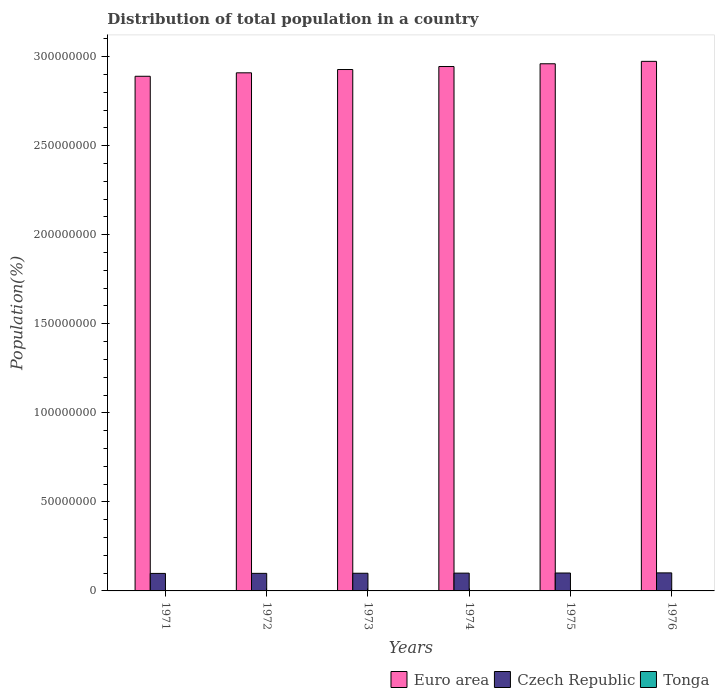How many different coloured bars are there?
Your response must be concise. 3. Are the number of bars per tick equal to the number of legend labels?
Provide a succinct answer. Yes. Are the number of bars on each tick of the X-axis equal?
Your answer should be very brief. Yes. How many bars are there on the 3rd tick from the left?
Ensure brevity in your answer.  3. How many bars are there on the 1st tick from the right?
Provide a short and direct response. 3. What is the label of the 6th group of bars from the left?
Make the answer very short. 1976. In how many cases, is the number of bars for a given year not equal to the number of legend labels?
Offer a terse response. 0. What is the population of in Tonga in 1974?
Offer a very short reply. 8.76e+04. Across all years, what is the maximum population of in Euro area?
Provide a succinct answer. 2.97e+08. Across all years, what is the minimum population of in Euro area?
Offer a terse response. 2.89e+08. In which year was the population of in Czech Republic maximum?
Offer a terse response. 1976. What is the total population of in Czech Republic in the graph?
Offer a terse response. 5.98e+07. What is the difference between the population of in Euro area in 1975 and that in 1976?
Your answer should be compact. -1.36e+06. What is the difference between the population of in Tonga in 1976 and the population of in Euro area in 1972?
Ensure brevity in your answer.  -2.91e+08. What is the average population of in Euro area per year?
Give a very brief answer. 2.93e+08. In the year 1972, what is the difference between the population of in Tonga and population of in Czech Republic?
Offer a very short reply. -9.78e+06. In how many years, is the population of in Czech Republic greater than 260000000 %?
Provide a short and direct response. 0. What is the ratio of the population of in Czech Republic in 1971 to that in 1973?
Offer a very short reply. 0.99. Is the population of in Euro area in 1973 less than that in 1975?
Keep it short and to the point. Yes. Is the difference between the population of in Tonga in 1972 and 1974 greater than the difference between the population of in Czech Republic in 1972 and 1974?
Your answer should be very brief. Yes. What is the difference between the highest and the second highest population of in Czech Republic?
Keep it short and to the point. 6.73e+04. What is the difference between the highest and the lowest population of in Tonga?
Offer a very short reply. 3738. What does the 2nd bar from the left in 1976 represents?
Give a very brief answer. Czech Republic. What does the 3rd bar from the right in 1973 represents?
Provide a short and direct response. Euro area. What is the difference between two consecutive major ticks on the Y-axis?
Your answer should be very brief. 5.00e+07. Are the values on the major ticks of Y-axis written in scientific E-notation?
Offer a very short reply. No. Where does the legend appear in the graph?
Your answer should be compact. Bottom right. How many legend labels are there?
Ensure brevity in your answer.  3. What is the title of the graph?
Ensure brevity in your answer.  Distribution of total population in a country. What is the label or title of the X-axis?
Ensure brevity in your answer.  Years. What is the label or title of the Y-axis?
Provide a succinct answer. Population(%). What is the Population(%) of Euro area in 1971?
Offer a very short reply. 2.89e+08. What is the Population(%) of Czech Republic in 1971?
Keep it short and to the point. 9.83e+06. What is the Population(%) in Tonga in 1971?
Ensure brevity in your answer.  8.55e+04. What is the Population(%) of Euro area in 1972?
Offer a very short reply. 2.91e+08. What is the Population(%) of Czech Republic in 1972?
Offer a terse response. 9.87e+06. What is the Population(%) of Tonga in 1972?
Provide a short and direct response. 8.63e+04. What is the Population(%) in Euro area in 1973?
Give a very brief answer. 2.93e+08. What is the Population(%) in Czech Republic in 1973?
Your answer should be very brief. 9.92e+06. What is the Population(%) in Tonga in 1973?
Offer a terse response. 8.70e+04. What is the Population(%) of Euro area in 1974?
Make the answer very short. 2.94e+08. What is the Population(%) of Czech Republic in 1974?
Provide a short and direct response. 9.99e+06. What is the Population(%) of Tonga in 1974?
Offer a terse response. 8.76e+04. What is the Population(%) in Euro area in 1975?
Your answer should be compact. 2.96e+08. What is the Population(%) in Czech Republic in 1975?
Give a very brief answer. 1.01e+07. What is the Population(%) of Tonga in 1975?
Keep it short and to the point. 8.83e+04. What is the Population(%) of Euro area in 1976?
Provide a short and direct response. 2.97e+08. What is the Population(%) in Czech Republic in 1976?
Offer a very short reply. 1.01e+07. What is the Population(%) of Tonga in 1976?
Your response must be concise. 8.93e+04. Across all years, what is the maximum Population(%) in Euro area?
Offer a very short reply. 2.97e+08. Across all years, what is the maximum Population(%) in Czech Republic?
Ensure brevity in your answer.  1.01e+07. Across all years, what is the maximum Population(%) in Tonga?
Provide a succinct answer. 8.93e+04. Across all years, what is the minimum Population(%) of Euro area?
Your answer should be compact. 2.89e+08. Across all years, what is the minimum Population(%) of Czech Republic?
Offer a terse response. 9.83e+06. Across all years, what is the minimum Population(%) in Tonga?
Offer a terse response. 8.55e+04. What is the total Population(%) in Euro area in the graph?
Give a very brief answer. 1.76e+09. What is the total Population(%) in Czech Republic in the graph?
Your response must be concise. 5.98e+07. What is the total Population(%) in Tonga in the graph?
Your answer should be compact. 5.24e+05. What is the difference between the Population(%) in Euro area in 1971 and that in 1972?
Offer a terse response. -1.94e+06. What is the difference between the Population(%) in Czech Republic in 1971 and that in 1972?
Provide a short and direct response. -4.08e+04. What is the difference between the Population(%) in Tonga in 1971 and that in 1972?
Provide a short and direct response. -829. What is the difference between the Population(%) in Euro area in 1971 and that in 1973?
Provide a succinct answer. -3.79e+06. What is the difference between the Population(%) of Czech Republic in 1971 and that in 1973?
Offer a very short reply. -9.55e+04. What is the difference between the Population(%) in Tonga in 1971 and that in 1973?
Ensure brevity in your answer.  -1465. What is the difference between the Population(%) of Euro area in 1971 and that in 1974?
Provide a short and direct response. -5.47e+06. What is the difference between the Population(%) in Czech Republic in 1971 and that in 1974?
Your answer should be compact. -1.62e+05. What is the difference between the Population(%) in Tonga in 1971 and that in 1974?
Give a very brief answer. -2089. What is the difference between the Population(%) of Euro area in 1971 and that in 1975?
Your answer should be compact. -7.02e+06. What is the difference between the Population(%) in Czech Republic in 1971 and that in 1975?
Offer a very short reply. -2.32e+05. What is the difference between the Population(%) in Tonga in 1971 and that in 1975?
Make the answer very short. -2827. What is the difference between the Population(%) in Euro area in 1971 and that in 1976?
Make the answer very short. -8.37e+06. What is the difference between the Population(%) of Czech Republic in 1971 and that in 1976?
Give a very brief answer. -2.99e+05. What is the difference between the Population(%) in Tonga in 1971 and that in 1976?
Your answer should be very brief. -3738. What is the difference between the Population(%) in Euro area in 1972 and that in 1973?
Offer a very short reply. -1.85e+06. What is the difference between the Population(%) of Czech Republic in 1972 and that in 1973?
Your answer should be compact. -5.46e+04. What is the difference between the Population(%) of Tonga in 1972 and that in 1973?
Give a very brief answer. -636. What is the difference between the Population(%) of Euro area in 1972 and that in 1974?
Provide a short and direct response. -3.53e+06. What is the difference between the Population(%) in Czech Republic in 1972 and that in 1974?
Offer a terse response. -1.21e+05. What is the difference between the Population(%) of Tonga in 1972 and that in 1974?
Keep it short and to the point. -1260. What is the difference between the Population(%) in Euro area in 1972 and that in 1975?
Provide a short and direct response. -5.08e+06. What is the difference between the Population(%) in Czech Republic in 1972 and that in 1975?
Keep it short and to the point. -1.91e+05. What is the difference between the Population(%) of Tonga in 1972 and that in 1975?
Provide a succinct answer. -1998. What is the difference between the Population(%) of Euro area in 1972 and that in 1976?
Keep it short and to the point. -6.44e+06. What is the difference between the Population(%) in Czech Republic in 1972 and that in 1976?
Ensure brevity in your answer.  -2.58e+05. What is the difference between the Population(%) in Tonga in 1972 and that in 1976?
Keep it short and to the point. -2909. What is the difference between the Population(%) in Euro area in 1973 and that in 1974?
Offer a terse response. -1.68e+06. What is the difference between the Population(%) of Czech Republic in 1973 and that in 1974?
Provide a succinct answer. -6.62e+04. What is the difference between the Population(%) in Tonga in 1973 and that in 1974?
Your answer should be very brief. -624. What is the difference between the Population(%) in Euro area in 1973 and that in 1975?
Your response must be concise. -3.23e+06. What is the difference between the Population(%) of Czech Republic in 1973 and that in 1975?
Your answer should be compact. -1.36e+05. What is the difference between the Population(%) in Tonga in 1973 and that in 1975?
Your answer should be very brief. -1362. What is the difference between the Population(%) in Euro area in 1973 and that in 1976?
Provide a short and direct response. -4.58e+06. What is the difference between the Population(%) in Czech Republic in 1973 and that in 1976?
Make the answer very short. -2.04e+05. What is the difference between the Population(%) of Tonga in 1973 and that in 1976?
Your answer should be very brief. -2273. What is the difference between the Population(%) in Euro area in 1974 and that in 1975?
Make the answer very short. -1.55e+06. What is the difference between the Population(%) of Czech Republic in 1974 and that in 1975?
Provide a succinct answer. -7.02e+04. What is the difference between the Population(%) in Tonga in 1974 and that in 1975?
Give a very brief answer. -738. What is the difference between the Population(%) of Euro area in 1974 and that in 1976?
Your answer should be very brief. -2.90e+06. What is the difference between the Population(%) in Czech Republic in 1974 and that in 1976?
Your answer should be compact. -1.37e+05. What is the difference between the Population(%) in Tonga in 1974 and that in 1976?
Your answer should be very brief. -1649. What is the difference between the Population(%) in Euro area in 1975 and that in 1976?
Make the answer very short. -1.36e+06. What is the difference between the Population(%) in Czech Republic in 1975 and that in 1976?
Offer a terse response. -6.73e+04. What is the difference between the Population(%) of Tonga in 1975 and that in 1976?
Offer a very short reply. -911. What is the difference between the Population(%) in Euro area in 1971 and the Population(%) in Czech Republic in 1972?
Provide a short and direct response. 2.79e+08. What is the difference between the Population(%) in Euro area in 1971 and the Population(%) in Tonga in 1972?
Provide a succinct answer. 2.89e+08. What is the difference between the Population(%) in Czech Republic in 1971 and the Population(%) in Tonga in 1972?
Give a very brief answer. 9.74e+06. What is the difference between the Population(%) in Euro area in 1971 and the Population(%) in Czech Republic in 1973?
Provide a succinct answer. 2.79e+08. What is the difference between the Population(%) of Euro area in 1971 and the Population(%) of Tonga in 1973?
Your response must be concise. 2.89e+08. What is the difference between the Population(%) of Czech Republic in 1971 and the Population(%) of Tonga in 1973?
Your answer should be very brief. 9.74e+06. What is the difference between the Population(%) in Euro area in 1971 and the Population(%) in Czech Republic in 1974?
Make the answer very short. 2.79e+08. What is the difference between the Population(%) in Euro area in 1971 and the Population(%) in Tonga in 1974?
Make the answer very short. 2.89e+08. What is the difference between the Population(%) of Czech Republic in 1971 and the Population(%) of Tonga in 1974?
Your response must be concise. 9.74e+06. What is the difference between the Population(%) of Euro area in 1971 and the Population(%) of Czech Republic in 1975?
Your answer should be compact. 2.79e+08. What is the difference between the Population(%) of Euro area in 1971 and the Population(%) of Tonga in 1975?
Your response must be concise. 2.89e+08. What is the difference between the Population(%) of Czech Republic in 1971 and the Population(%) of Tonga in 1975?
Provide a short and direct response. 9.74e+06. What is the difference between the Population(%) in Euro area in 1971 and the Population(%) in Czech Republic in 1976?
Your response must be concise. 2.79e+08. What is the difference between the Population(%) of Euro area in 1971 and the Population(%) of Tonga in 1976?
Ensure brevity in your answer.  2.89e+08. What is the difference between the Population(%) of Czech Republic in 1971 and the Population(%) of Tonga in 1976?
Your response must be concise. 9.74e+06. What is the difference between the Population(%) of Euro area in 1972 and the Population(%) of Czech Republic in 1973?
Keep it short and to the point. 2.81e+08. What is the difference between the Population(%) of Euro area in 1972 and the Population(%) of Tonga in 1973?
Make the answer very short. 2.91e+08. What is the difference between the Population(%) of Czech Republic in 1972 and the Population(%) of Tonga in 1973?
Your answer should be very brief. 9.78e+06. What is the difference between the Population(%) in Euro area in 1972 and the Population(%) in Czech Republic in 1974?
Your answer should be very brief. 2.81e+08. What is the difference between the Population(%) in Euro area in 1972 and the Population(%) in Tonga in 1974?
Provide a succinct answer. 2.91e+08. What is the difference between the Population(%) of Czech Republic in 1972 and the Population(%) of Tonga in 1974?
Your response must be concise. 9.78e+06. What is the difference between the Population(%) in Euro area in 1972 and the Population(%) in Czech Republic in 1975?
Your answer should be compact. 2.81e+08. What is the difference between the Population(%) in Euro area in 1972 and the Population(%) in Tonga in 1975?
Your answer should be very brief. 2.91e+08. What is the difference between the Population(%) in Czech Republic in 1972 and the Population(%) in Tonga in 1975?
Offer a terse response. 9.78e+06. What is the difference between the Population(%) in Euro area in 1972 and the Population(%) in Czech Republic in 1976?
Offer a very short reply. 2.81e+08. What is the difference between the Population(%) in Euro area in 1972 and the Population(%) in Tonga in 1976?
Make the answer very short. 2.91e+08. What is the difference between the Population(%) in Czech Republic in 1972 and the Population(%) in Tonga in 1976?
Ensure brevity in your answer.  9.78e+06. What is the difference between the Population(%) of Euro area in 1973 and the Population(%) of Czech Republic in 1974?
Provide a succinct answer. 2.83e+08. What is the difference between the Population(%) in Euro area in 1973 and the Population(%) in Tonga in 1974?
Offer a very short reply. 2.93e+08. What is the difference between the Population(%) of Czech Republic in 1973 and the Population(%) of Tonga in 1974?
Provide a succinct answer. 9.83e+06. What is the difference between the Population(%) of Euro area in 1973 and the Population(%) of Czech Republic in 1975?
Make the answer very short. 2.83e+08. What is the difference between the Population(%) in Euro area in 1973 and the Population(%) in Tonga in 1975?
Keep it short and to the point. 2.93e+08. What is the difference between the Population(%) of Czech Republic in 1973 and the Population(%) of Tonga in 1975?
Offer a very short reply. 9.83e+06. What is the difference between the Population(%) of Euro area in 1973 and the Population(%) of Czech Republic in 1976?
Offer a very short reply. 2.83e+08. What is the difference between the Population(%) of Euro area in 1973 and the Population(%) of Tonga in 1976?
Provide a succinct answer. 2.93e+08. What is the difference between the Population(%) of Czech Republic in 1973 and the Population(%) of Tonga in 1976?
Give a very brief answer. 9.83e+06. What is the difference between the Population(%) of Euro area in 1974 and the Population(%) of Czech Republic in 1975?
Make the answer very short. 2.84e+08. What is the difference between the Population(%) of Euro area in 1974 and the Population(%) of Tonga in 1975?
Provide a short and direct response. 2.94e+08. What is the difference between the Population(%) in Czech Republic in 1974 and the Population(%) in Tonga in 1975?
Ensure brevity in your answer.  9.90e+06. What is the difference between the Population(%) in Euro area in 1974 and the Population(%) in Czech Republic in 1976?
Keep it short and to the point. 2.84e+08. What is the difference between the Population(%) in Euro area in 1974 and the Population(%) in Tonga in 1976?
Your answer should be compact. 2.94e+08. What is the difference between the Population(%) of Czech Republic in 1974 and the Population(%) of Tonga in 1976?
Make the answer very short. 9.90e+06. What is the difference between the Population(%) in Euro area in 1975 and the Population(%) in Czech Republic in 1976?
Make the answer very short. 2.86e+08. What is the difference between the Population(%) of Euro area in 1975 and the Population(%) of Tonga in 1976?
Offer a terse response. 2.96e+08. What is the difference between the Population(%) of Czech Republic in 1975 and the Population(%) of Tonga in 1976?
Ensure brevity in your answer.  9.97e+06. What is the average Population(%) of Euro area per year?
Keep it short and to the point. 2.93e+08. What is the average Population(%) of Czech Republic per year?
Your answer should be very brief. 9.96e+06. What is the average Population(%) of Tonga per year?
Make the answer very short. 8.73e+04. In the year 1971, what is the difference between the Population(%) of Euro area and Population(%) of Czech Republic?
Keep it short and to the point. 2.79e+08. In the year 1971, what is the difference between the Population(%) in Euro area and Population(%) in Tonga?
Your response must be concise. 2.89e+08. In the year 1971, what is the difference between the Population(%) in Czech Republic and Population(%) in Tonga?
Ensure brevity in your answer.  9.74e+06. In the year 1972, what is the difference between the Population(%) in Euro area and Population(%) in Czech Republic?
Your answer should be compact. 2.81e+08. In the year 1972, what is the difference between the Population(%) of Euro area and Population(%) of Tonga?
Provide a succinct answer. 2.91e+08. In the year 1972, what is the difference between the Population(%) of Czech Republic and Population(%) of Tonga?
Make the answer very short. 9.78e+06. In the year 1973, what is the difference between the Population(%) of Euro area and Population(%) of Czech Republic?
Your answer should be very brief. 2.83e+08. In the year 1973, what is the difference between the Population(%) in Euro area and Population(%) in Tonga?
Your answer should be very brief. 2.93e+08. In the year 1973, what is the difference between the Population(%) of Czech Republic and Population(%) of Tonga?
Make the answer very short. 9.84e+06. In the year 1974, what is the difference between the Population(%) of Euro area and Population(%) of Czech Republic?
Your answer should be compact. 2.84e+08. In the year 1974, what is the difference between the Population(%) in Euro area and Population(%) in Tonga?
Your answer should be very brief. 2.94e+08. In the year 1974, what is the difference between the Population(%) in Czech Republic and Population(%) in Tonga?
Make the answer very short. 9.90e+06. In the year 1975, what is the difference between the Population(%) in Euro area and Population(%) in Czech Republic?
Give a very brief answer. 2.86e+08. In the year 1975, what is the difference between the Population(%) in Euro area and Population(%) in Tonga?
Your response must be concise. 2.96e+08. In the year 1975, what is the difference between the Population(%) of Czech Republic and Population(%) of Tonga?
Your response must be concise. 9.97e+06. In the year 1976, what is the difference between the Population(%) in Euro area and Population(%) in Czech Republic?
Give a very brief answer. 2.87e+08. In the year 1976, what is the difference between the Population(%) in Euro area and Population(%) in Tonga?
Offer a very short reply. 2.97e+08. In the year 1976, what is the difference between the Population(%) of Czech Republic and Population(%) of Tonga?
Your response must be concise. 1.00e+07. What is the ratio of the Population(%) in Czech Republic in 1971 to that in 1972?
Your answer should be very brief. 1. What is the ratio of the Population(%) in Tonga in 1971 to that in 1972?
Your response must be concise. 0.99. What is the ratio of the Population(%) of Euro area in 1971 to that in 1973?
Provide a succinct answer. 0.99. What is the ratio of the Population(%) in Czech Republic in 1971 to that in 1973?
Provide a short and direct response. 0.99. What is the ratio of the Population(%) in Tonga in 1971 to that in 1973?
Offer a terse response. 0.98. What is the ratio of the Population(%) in Euro area in 1971 to that in 1974?
Your response must be concise. 0.98. What is the ratio of the Population(%) of Czech Republic in 1971 to that in 1974?
Provide a short and direct response. 0.98. What is the ratio of the Population(%) of Tonga in 1971 to that in 1974?
Give a very brief answer. 0.98. What is the ratio of the Population(%) of Euro area in 1971 to that in 1975?
Your response must be concise. 0.98. What is the ratio of the Population(%) of Tonga in 1971 to that in 1975?
Your answer should be compact. 0.97. What is the ratio of the Population(%) in Euro area in 1971 to that in 1976?
Keep it short and to the point. 0.97. What is the ratio of the Population(%) of Czech Republic in 1971 to that in 1976?
Your answer should be very brief. 0.97. What is the ratio of the Population(%) in Tonga in 1971 to that in 1976?
Ensure brevity in your answer.  0.96. What is the ratio of the Population(%) of Tonga in 1972 to that in 1973?
Give a very brief answer. 0.99. What is the ratio of the Population(%) of Euro area in 1972 to that in 1974?
Give a very brief answer. 0.99. What is the ratio of the Population(%) in Czech Republic in 1972 to that in 1974?
Make the answer very short. 0.99. What is the ratio of the Population(%) of Tonga in 1972 to that in 1974?
Ensure brevity in your answer.  0.99. What is the ratio of the Population(%) of Euro area in 1972 to that in 1975?
Keep it short and to the point. 0.98. What is the ratio of the Population(%) of Tonga in 1972 to that in 1975?
Your answer should be compact. 0.98. What is the ratio of the Population(%) in Euro area in 1972 to that in 1976?
Your answer should be very brief. 0.98. What is the ratio of the Population(%) of Czech Republic in 1972 to that in 1976?
Your answer should be very brief. 0.97. What is the ratio of the Population(%) of Tonga in 1972 to that in 1976?
Your answer should be very brief. 0.97. What is the ratio of the Population(%) in Czech Republic in 1973 to that in 1974?
Offer a very short reply. 0.99. What is the ratio of the Population(%) in Czech Republic in 1973 to that in 1975?
Ensure brevity in your answer.  0.99. What is the ratio of the Population(%) in Tonga in 1973 to that in 1975?
Keep it short and to the point. 0.98. What is the ratio of the Population(%) in Euro area in 1973 to that in 1976?
Ensure brevity in your answer.  0.98. What is the ratio of the Population(%) of Czech Republic in 1973 to that in 1976?
Your answer should be very brief. 0.98. What is the ratio of the Population(%) in Tonga in 1973 to that in 1976?
Keep it short and to the point. 0.97. What is the ratio of the Population(%) of Euro area in 1974 to that in 1975?
Your answer should be very brief. 0.99. What is the ratio of the Population(%) in Euro area in 1974 to that in 1976?
Your answer should be very brief. 0.99. What is the ratio of the Population(%) of Czech Republic in 1974 to that in 1976?
Offer a terse response. 0.99. What is the ratio of the Population(%) of Tonga in 1974 to that in 1976?
Make the answer very short. 0.98. What is the ratio of the Population(%) of Euro area in 1975 to that in 1976?
Ensure brevity in your answer.  1. What is the ratio of the Population(%) in Czech Republic in 1975 to that in 1976?
Make the answer very short. 0.99. What is the difference between the highest and the second highest Population(%) of Euro area?
Provide a short and direct response. 1.36e+06. What is the difference between the highest and the second highest Population(%) of Czech Republic?
Offer a very short reply. 6.73e+04. What is the difference between the highest and the second highest Population(%) in Tonga?
Offer a very short reply. 911. What is the difference between the highest and the lowest Population(%) of Euro area?
Provide a short and direct response. 8.37e+06. What is the difference between the highest and the lowest Population(%) of Czech Republic?
Provide a succinct answer. 2.99e+05. What is the difference between the highest and the lowest Population(%) in Tonga?
Your response must be concise. 3738. 